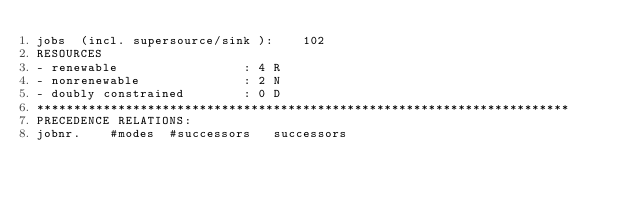Convert code to text. <code><loc_0><loc_0><loc_500><loc_500><_ObjectiveC_>jobs  (incl. supersource/sink ):	102
RESOURCES
- renewable                 : 4 R
- nonrenewable              : 2 N
- doubly constrained        : 0 D
************************************************************************
PRECEDENCE RELATIONS:
jobnr.    #modes  #successors   successors</code> 